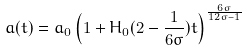<formula> <loc_0><loc_0><loc_500><loc_500>a ( t ) = a _ { 0 } \left ( 1 + H _ { 0 } ( 2 - \frac { 1 } { 6 \sigma } ) t \right ) ^ { \frac { 6 \sigma } { 1 2 \sigma - 1 } }</formula> 